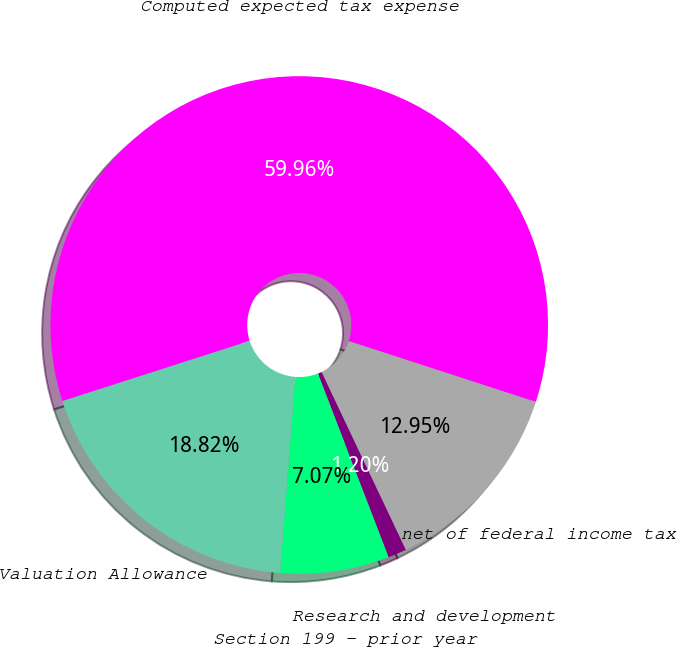Convert chart to OTSL. <chart><loc_0><loc_0><loc_500><loc_500><pie_chart><fcel>Computed expected tax expense<fcel>net of federal income tax<fcel>Research and development<fcel>Section 199 - prior year<fcel>Valuation Allowance<nl><fcel>59.95%<fcel>12.95%<fcel>1.2%<fcel>7.07%<fcel>18.82%<nl></chart> 